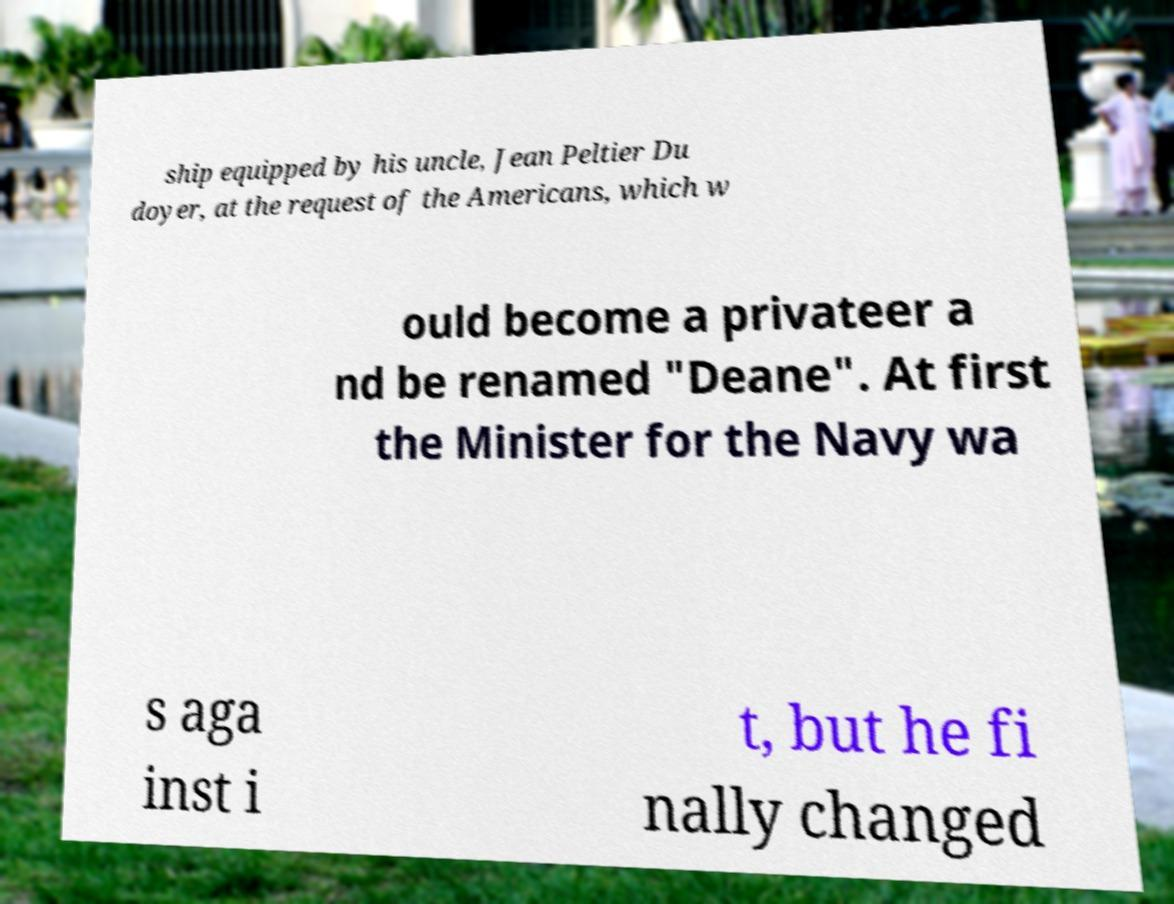Can you accurately transcribe the text from the provided image for me? ship equipped by his uncle, Jean Peltier Du doyer, at the request of the Americans, which w ould become a privateer a nd be renamed "Deane". At first the Minister for the Navy wa s aga inst i t, but he fi nally changed 